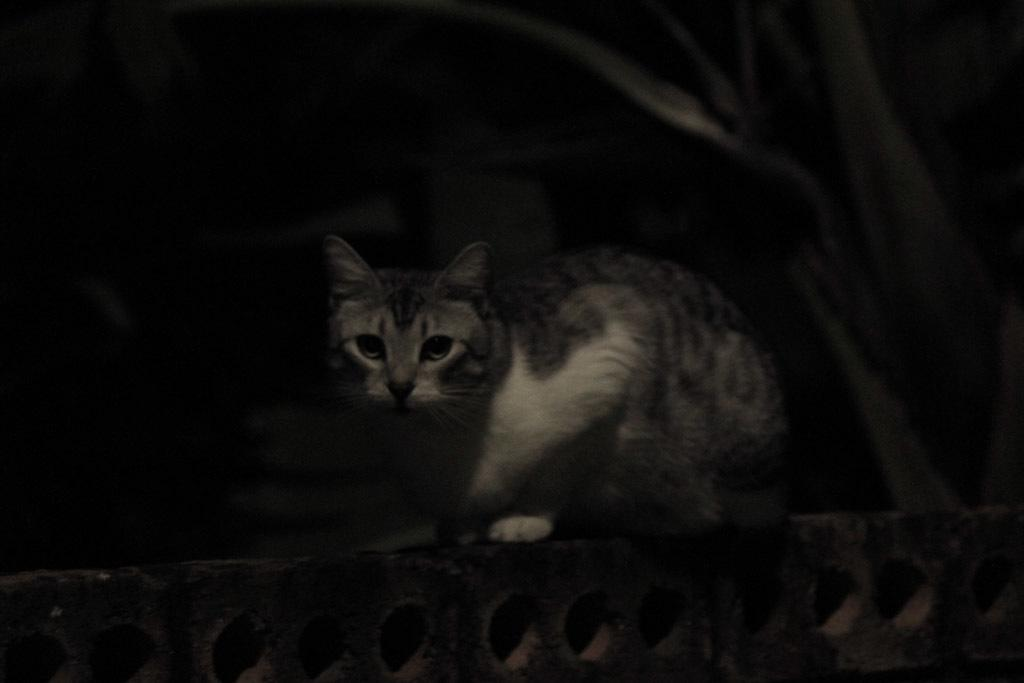What animal is present in the image? There is a cat in the image. What is the cat doing in the image? The cat is sitting on a surface. What can be observed about the background of the image? The background of the image is dark. What type of music is the cat playing in the image? There is no music or instrument present in the image, so the cat cannot be playing any music. 